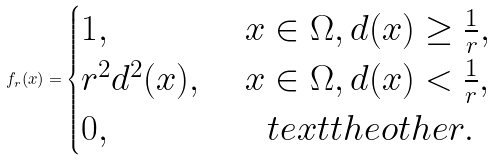<formula> <loc_0><loc_0><loc_500><loc_500>f _ { r } ( x ) = \begin{cases} 1 , & \ x \in \Omega , d ( x ) \geq \frac { 1 } { r } , \\ r ^ { 2 } d ^ { 2 } ( x ) , & \ x \in \Omega , d ( x ) < \frac { 1 } { r } , \\ 0 , & \quad t e x t { t h e o t h e r } . \end{cases}</formula> 